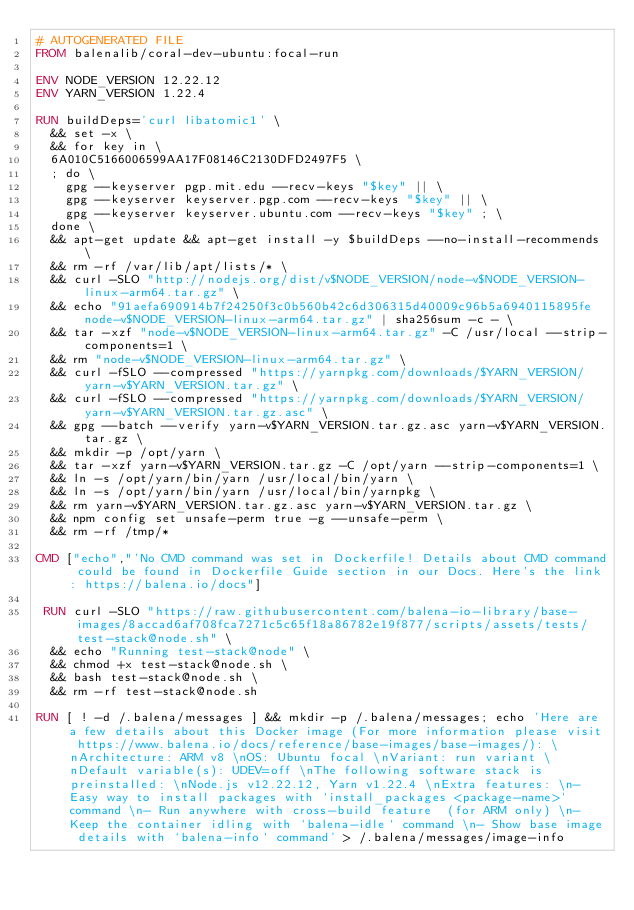<code> <loc_0><loc_0><loc_500><loc_500><_Dockerfile_># AUTOGENERATED FILE
FROM balenalib/coral-dev-ubuntu:focal-run

ENV NODE_VERSION 12.22.12
ENV YARN_VERSION 1.22.4

RUN buildDeps='curl libatomic1' \
	&& set -x \
	&& for key in \
	6A010C5166006599AA17F08146C2130DFD2497F5 \
	; do \
		gpg --keyserver pgp.mit.edu --recv-keys "$key" || \
		gpg --keyserver keyserver.pgp.com --recv-keys "$key" || \
		gpg --keyserver keyserver.ubuntu.com --recv-keys "$key" ; \
	done \
	&& apt-get update && apt-get install -y $buildDeps --no-install-recommends \
	&& rm -rf /var/lib/apt/lists/* \
	&& curl -SLO "http://nodejs.org/dist/v$NODE_VERSION/node-v$NODE_VERSION-linux-arm64.tar.gz" \
	&& echo "91aefa690914b7f24250f3c0b560b42c6d306315d40009c96b5a6940115895fe  node-v$NODE_VERSION-linux-arm64.tar.gz" | sha256sum -c - \
	&& tar -xzf "node-v$NODE_VERSION-linux-arm64.tar.gz" -C /usr/local --strip-components=1 \
	&& rm "node-v$NODE_VERSION-linux-arm64.tar.gz" \
	&& curl -fSLO --compressed "https://yarnpkg.com/downloads/$YARN_VERSION/yarn-v$YARN_VERSION.tar.gz" \
	&& curl -fSLO --compressed "https://yarnpkg.com/downloads/$YARN_VERSION/yarn-v$YARN_VERSION.tar.gz.asc" \
	&& gpg --batch --verify yarn-v$YARN_VERSION.tar.gz.asc yarn-v$YARN_VERSION.tar.gz \
	&& mkdir -p /opt/yarn \
	&& tar -xzf yarn-v$YARN_VERSION.tar.gz -C /opt/yarn --strip-components=1 \
	&& ln -s /opt/yarn/bin/yarn /usr/local/bin/yarn \
	&& ln -s /opt/yarn/bin/yarn /usr/local/bin/yarnpkg \
	&& rm yarn-v$YARN_VERSION.tar.gz.asc yarn-v$YARN_VERSION.tar.gz \
	&& npm config set unsafe-perm true -g --unsafe-perm \
	&& rm -rf /tmp/*

CMD ["echo","'No CMD command was set in Dockerfile! Details about CMD command could be found in Dockerfile Guide section in our Docs. Here's the link: https://balena.io/docs"]

 RUN curl -SLO "https://raw.githubusercontent.com/balena-io-library/base-images/8accad6af708fca7271c5c65f18a86782e19f877/scripts/assets/tests/test-stack@node.sh" \
  && echo "Running test-stack@node" \
  && chmod +x test-stack@node.sh \
  && bash test-stack@node.sh \
  && rm -rf test-stack@node.sh 

RUN [ ! -d /.balena/messages ] && mkdir -p /.balena/messages; echo 'Here are a few details about this Docker image (For more information please visit https://www.balena.io/docs/reference/base-images/base-images/): \nArchitecture: ARM v8 \nOS: Ubuntu focal \nVariant: run variant \nDefault variable(s): UDEV=off \nThe following software stack is preinstalled: \nNode.js v12.22.12, Yarn v1.22.4 \nExtra features: \n- Easy way to install packages with `install_packages <package-name>` command \n- Run anywhere with cross-build feature  (for ARM only) \n- Keep the container idling with `balena-idle` command \n- Show base image details with `balena-info` command' > /.balena/messages/image-info</code> 